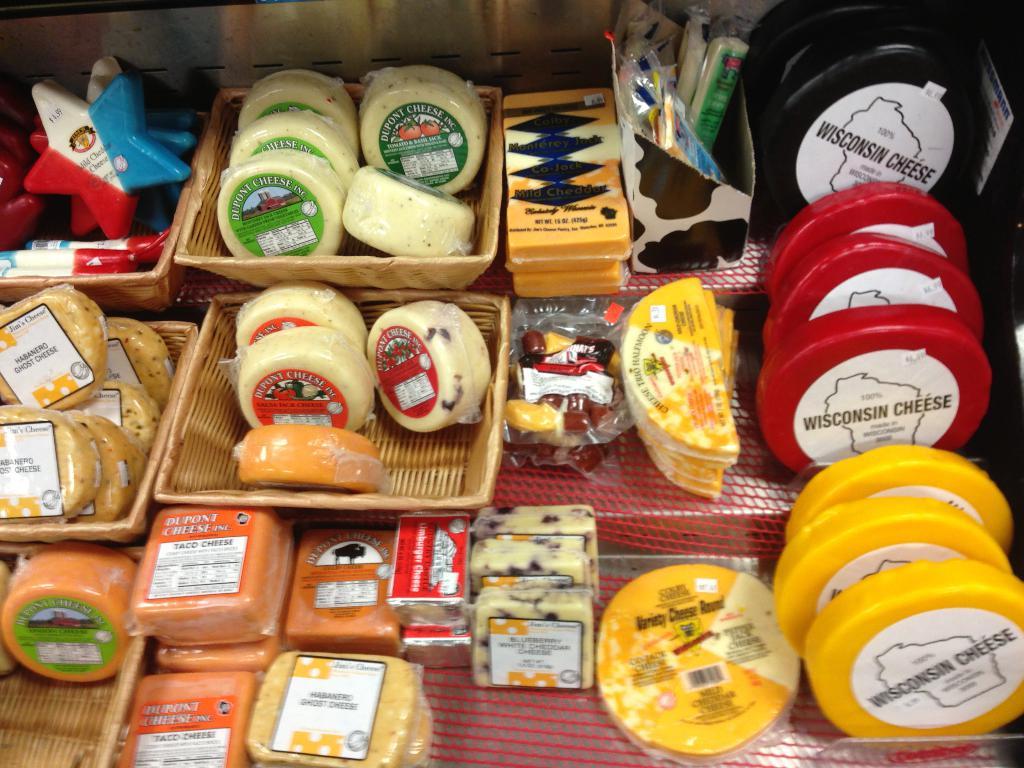Where are the large cheese wheels on the right made?
Provide a short and direct response. Wisconsin. Who makes the orange cheese on the left?
Offer a terse response. Dupont. 